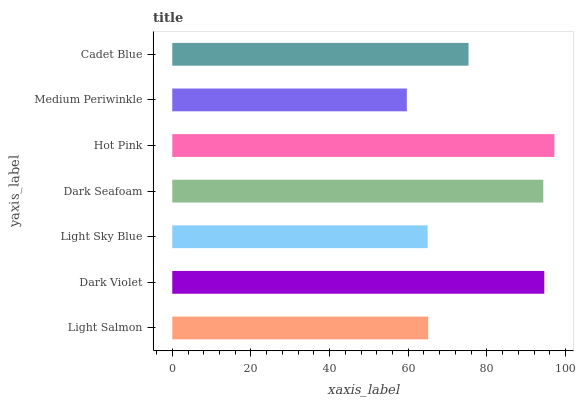Is Medium Periwinkle the minimum?
Answer yes or no. Yes. Is Hot Pink the maximum?
Answer yes or no. Yes. Is Dark Violet the minimum?
Answer yes or no. No. Is Dark Violet the maximum?
Answer yes or no. No. Is Dark Violet greater than Light Salmon?
Answer yes or no. Yes. Is Light Salmon less than Dark Violet?
Answer yes or no. Yes. Is Light Salmon greater than Dark Violet?
Answer yes or no. No. Is Dark Violet less than Light Salmon?
Answer yes or no. No. Is Cadet Blue the high median?
Answer yes or no. Yes. Is Cadet Blue the low median?
Answer yes or no. Yes. Is Light Sky Blue the high median?
Answer yes or no. No. Is Dark Violet the low median?
Answer yes or no. No. 